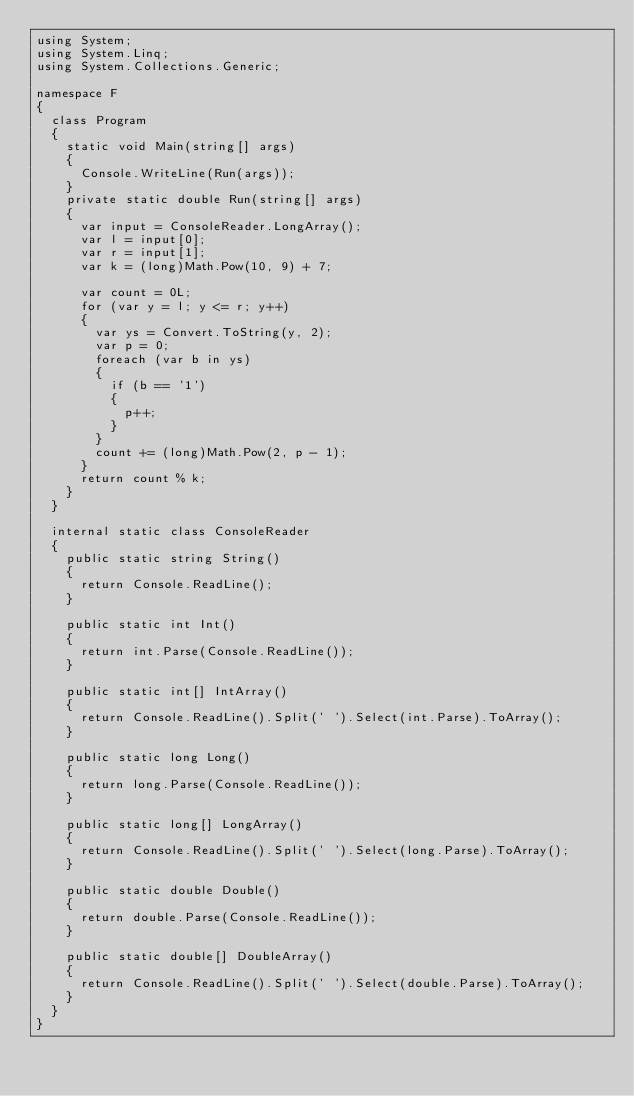<code> <loc_0><loc_0><loc_500><loc_500><_C#_>using System;
using System.Linq;
using System.Collections.Generic;

namespace F
{
  class Program
  {
    static void Main(string[] args)
    {
      Console.WriteLine(Run(args));
    }
    private static double Run(string[] args)
    {
      var input = ConsoleReader.LongArray();
      var l = input[0];
      var r = input[1];
      var k = (long)Math.Pow(10, 9) + 7;

      var count = 0L;
      for (var y = l; y <= r; y++)
      {
        var ys = Convert.ToString(y, 2);
        var p = 0;
        foreach (var b in ys)
        {
          if (b == '1')
          {
            p++;
          }
        }
        count += (long)Math.Pow(2, p - 1);
      }
      return count % k;
    }
  }

  internal static class ConsoleReader
  {
    public static string String()
    {
      return Console.ReadLine();
    }

    public static int Int()
    {
      return int.Parse(Console.ReadLine());
    }

    public static int[] IntArray()
    {
      return Console.ReadLine().Split(' ').Select(int.Parse).ToArray();
    }

    public static long Long()
    {
      return long.Parse(Console.ReadLine());
    }

    public static long[] LongArray()
    {
      return Console.ReadLine().Split(' ').Select(long.Parse).ToArray();
    }

    public static double Double()
    {
      return double.Parse(Console.ReadLine());
    }

    public static double[] DoubleArray()
    {
      return Console.ReadLine().Split(' ').Select(double.Parse).ToArray();
    }
  }
}
</code> 